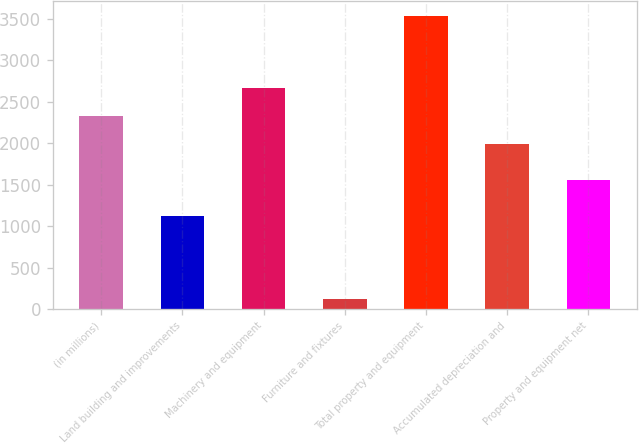<chart> <loc_0><loc_0><loc_500><loc_500><bar_chart><fcel>(in millions)<fcel>Land building and improvements<fcel>Machinery and equipment<fcel>Furniture and fixtures<fcel>Total property and equipment<fcel>Accumulated depreciation and<fcel>Property and equipment net<nl><fcel>2327.7<fcel>1126<fcel>2669.4<fcel>120<fcel>3537<fcel>1986<fcel>1551<nl></chart> 